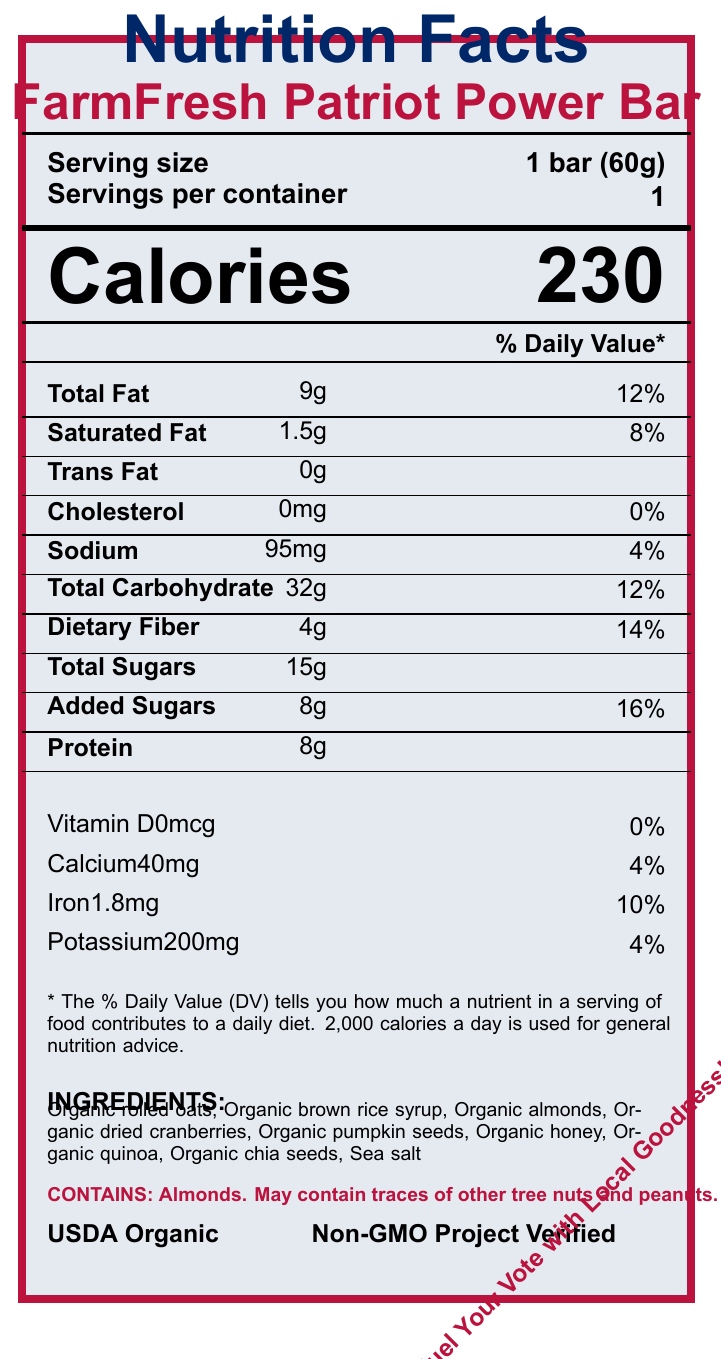what is the serving size? The serving size is clearly stated under the "Serving size" section in the document.
Answer: 1 bar (60g) how many calories are in one serving? The document lists the calories in one serving as 230, located prominently under the "Calories" section.
Answer: 230 What is the Total Fat content? The Total Fat content is listed as 9g in the nutrient table section of the document.
Answer: 9g What percentage of the daily value of Iron does the bar provide? The % Daily Value (DV) of Iron is listed as 10% in the vitamins and minerals section of the document.
Answer: 10% does the product contain any added sugars? The Added Sugars value is listed as 8g in the nutrient table, indicating that the product contains added sugars.
Answer: Yes Which of the following vitamins is not present in the FarmFresh Patriot Power Bar? A. Vitamin A B. Vitamin D C. Calcium D. Iron The document does not list Vitamin A under the vitamin and mineral information, whereas Vitamin D, Calcium, and Iron are mentioned.
Answer: A. Vitamin A How many grams of dietary fiber does the bar have? A. 3g B. 4g C. 5g D. 6g The Dietary Fiber content is listed as 4g in the nutrient table.
Answer: B. 4g True or False: The product is certified as USDA Organic. The certification section of the document explicitly lists "USDA Organic", confirming this certification.
Answer: True Summarize the main nutritional components of the FarmFresh Patriot Power Bar. The summary encapsulates the key nutritional details, ingredient list, and allergen information provided in the document.
Answer: The FarmFresh Patriot Power Bar contains 230 calories, 9g of total fat, 1.5g of saturated fat, 0g trans fat, 0mg cholesterol, 95mg sodium, 32g total carbohydrates, 4g dietary fiber, 15g total sugars (including 8g added sugars), and 8g protein. It also provides 0% DV of Vitamin D, 4% DV of Calcium, 10% DV of Iron, and 4% DV of Potassium. The ingredients are organic and include oats, brown rice syrup, almonds, cranberries, pumpkin seeds, honey, quinoa, chia seeds, and sea salt. It contains almonds and may have traces of other tree nuts and peanuts. what is the campaign slogan associated with the product? The campaign slogan is "Fuel Your Vote with Local Goodness!", found near the bottom of the document.
Answer: Fuel Your Vote with Local Goodness! where are the ingredients sourced from? The sourcing information specifies that the ingredients are sourced from family farms within 100 miles of the state capital.
Answer: Family farms within 100 miles of the state capital what kind of packaging does the product use? The eco-friendly packaging information states that the wrapper is made from 100% compostable materials.
Answer: 100% compostable materials How many grams of protein does one bar provide? The nutrient table lists the protein content as 8g.
Answer: 8g Is the FarmFresh Patriot Power Bar gluten-free? The document does not provide information regarding the gluten content or gluten-free certification of the product, making it impossible to determine based on the provided text.
Answer: Cannot be determined 